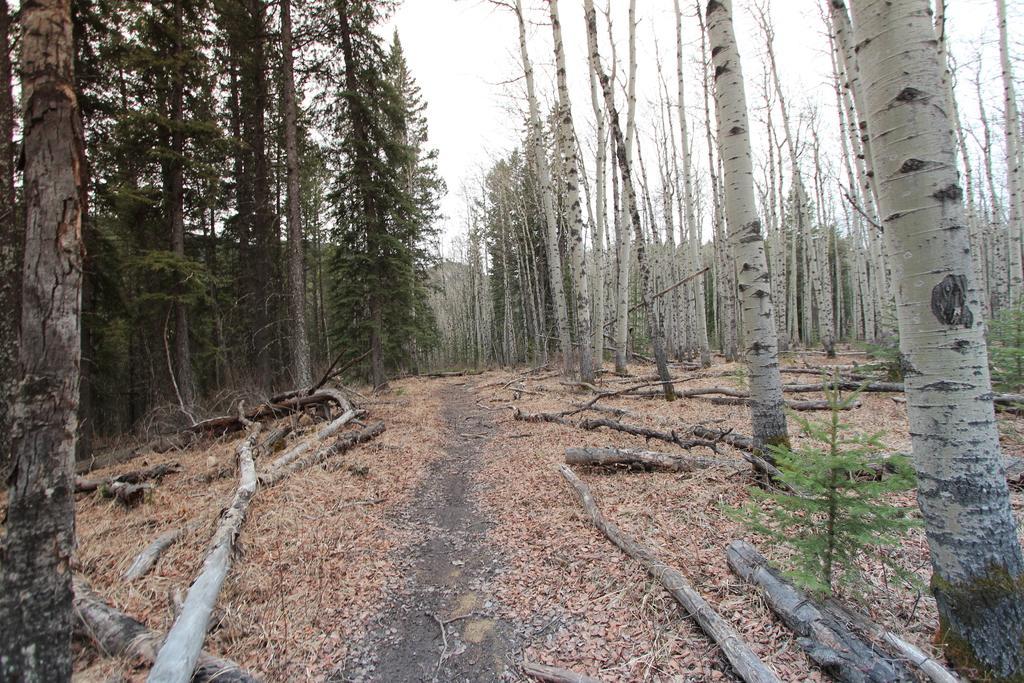Describe this image in one or two sentences. In this picture we can see trees on the right side and left side, at the bottom there are some leaves and wood, we can see a plant on the right side, there is the sky at the top of the picture. 